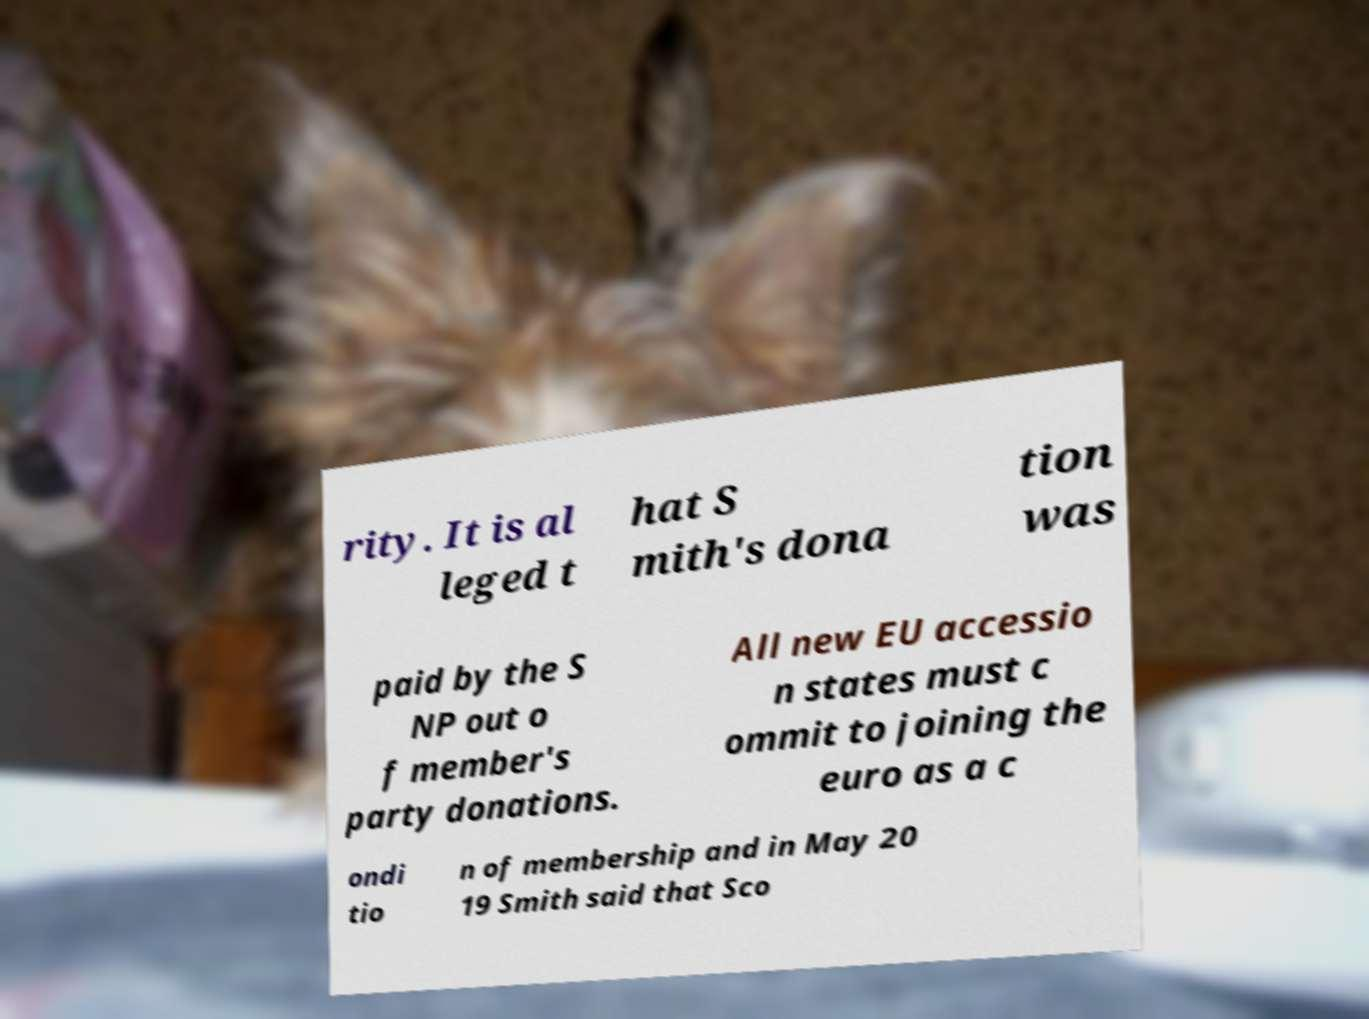Can you accurately transcribe the text from the provided image for me? rity. It is al leged t hat S mith's dona tion was paid by the S NP out o f member's party donations. All new EU accessio n states must c ommit to joining the euro as a c ondi tio n of membership and in May 20 19 Smith said that Sco 